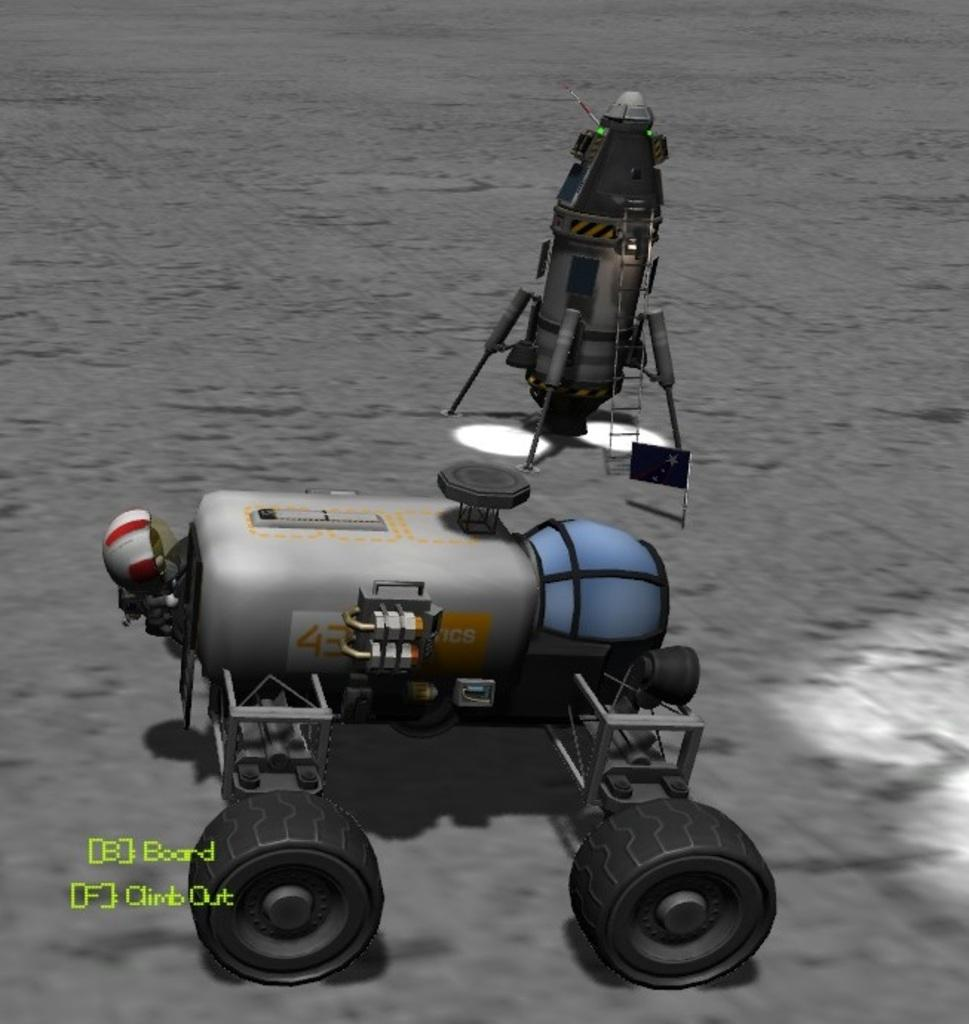<image>
Relay a brief, clear account of the picture shown. two computerized planet vehicles on a grey surface and one has the number 43 on it 